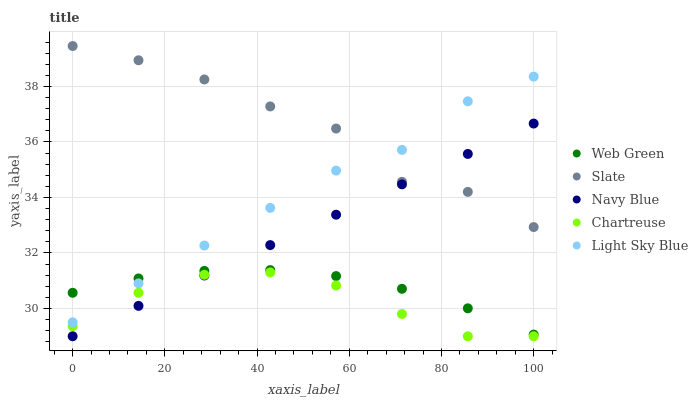Does Chartreuse have the minimum area under the curve?
Answer yes or no. Yes. Does Slate have the maximum area under the curve?
Answer yes or no. Yes. Does Light Sky Blue have the minimum area under the curve?
Answer yes or no. No. Does Light Sky Blue have the maximum area under the curve?
Answer yes or no. No. Is Navy Blue the smoothest?
Answer yes or no. Yes. Is Slate the roughest?
Answer yes or no. Yes. Is Light Sky Blue the smoothest?
Answer yes or no. No. Is Light Sky Blue the roughest?
Answer yes or no. No. Does Navy Blue have the lowest value?
Answer yes or no. Yes. Does Light Sky Blue have the lowest value?
Answer yes or no. No. Does Slate have the highest value?
Answer yes or no. Yes. Does Light Sky Blue have the highest value?
Answer yes or no. No. Is Chartreuse less than Slate?
Answer yes or no. Yes. Is Slate greater than Chartreuse?
Answer yes or no. Yes. Does Navy Blue intersect Slate?
Answer yes or no. Yes. Is Navy Blue less than Slate?
Answer yes or no. No. Is Navy Blue greater than Slate?
Answer yes or no. No. Does Chartreuse intersect Slate?
Answer yes or no. No. 